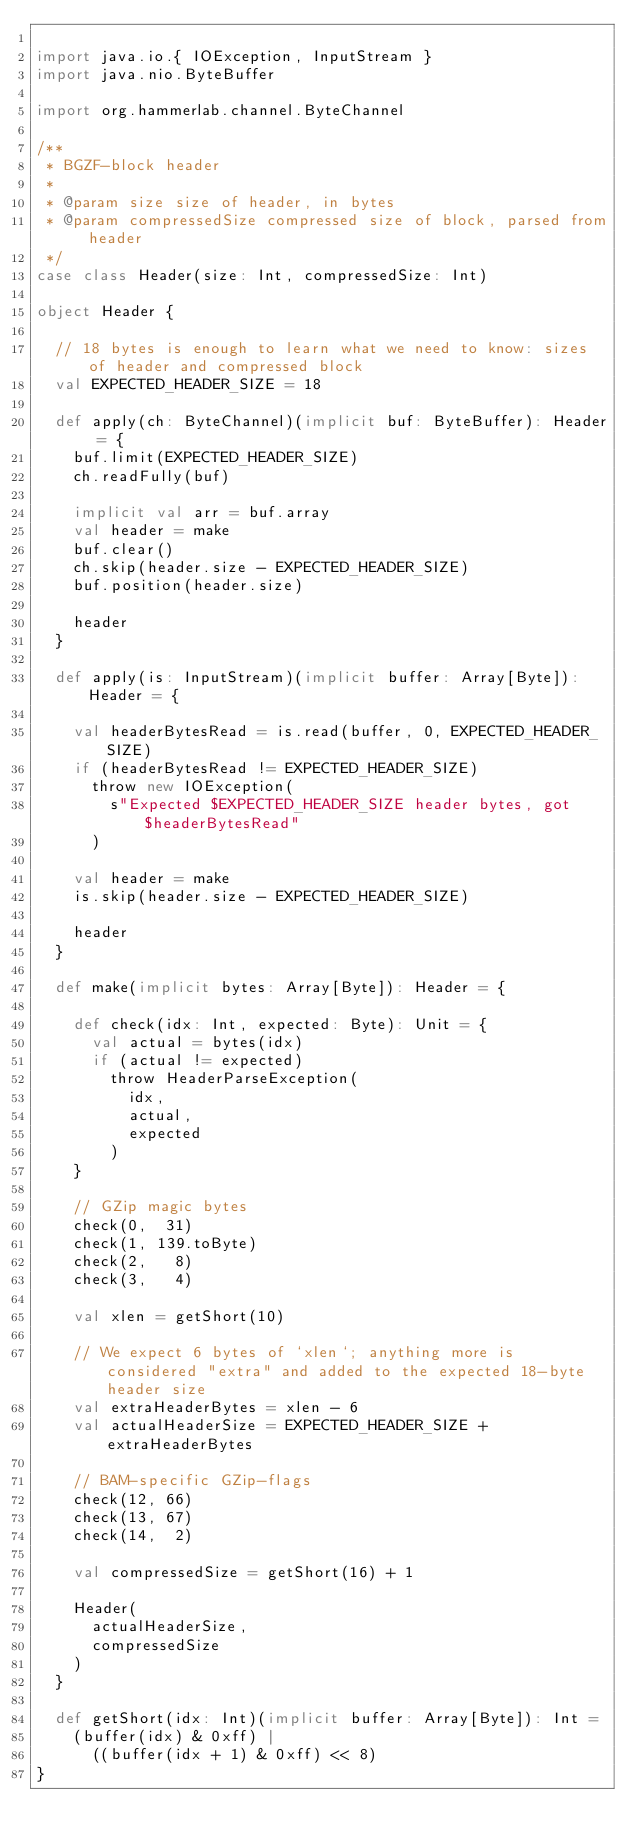Convert code to text. <code><loc_0><loc_0><loc_500><loc_500><_Scala_>
import java.io.{ IOException, InputStream }
import java.nio.ByteBuffer

import org.hammerlab.channel.ByteChannel

/**
 * BGZF-block header
 *
 * @param size size of header, in bytes
 * @param compressedSize compressed size of block, parsed from header
 */
case class Header(size: Int, compressedSize: Int)

object Header {

  // 18 bytes is enough to learn what we need to know: sizes of header and compressed block
  val EXPECTED_HEADER_SIZE = 18

  def apply(ch: ByteChannel)(implicit buf: ByteBuffer): Header = {
    buf.limit(EXPECTED_HEADER_SIZE)
    ch.readFully(buf)

    implicit val arr = buf.array
    val header = make
    buf.clear()
    ch.skip(header.size - EXPECTED_HEADER_SIZE)
    buf.position(header.size)

    header
  }

  def apply(is: InputStream)(implicit buffer: Array[Byte]): Header = {

    val headerBytesRead = is.read(buffer, 0, EXPECTED_HEADER_SIZE)
    if (headerBytesRead != EXPECTED_HEADER_SIZE)
      throw new IOException(
        s"Expected $EXPECTED_HEADER_SIZE header bytes, got $headerBytesRead"
      )

    val header = make
    is.skip(header.size - EXPECTED_HEADER_SIZE)

    header
  }

  def make(implicit bytes: Array[Byte]): Header = {

    def check(idx: Int, expected: Byte): Unit = {
      val actual = bytes(idx)
      if (actual != expected)
        throw HeaderParseException(
          idx,
          actual,
          expected
        )
    }

    // GZip magic bytes
    check(0,  31)
    check(1, 139.toByte)
    check(2,   8)
    check(3,   4)

    val xlen = getShort(10)

    // We expect 6 bytes of `xlen`; anything more is considered "extra" and added to the expected 18-byte header size
    val extraHeaderBytes = xlen - 6
    val actualHeaderSize = EXPECTED_HEADER_SIZE + extraHeaderBytes

    // BAM-specific GZip-flags
    check(12, 66)
    check(13, 67)
    check(14,  2)

    val compressedSize = getShort(16) + 1

    Header(
      actualHeaderSize,
      compressedSize
    )
  }

  def getShort(idx: Int)(implicit buffer: Array[Byte]): Int =
    (buffer(idx) & 0xff) |
      ((buffer(idx + 1) & 0xff) << 8)
}
</code> 